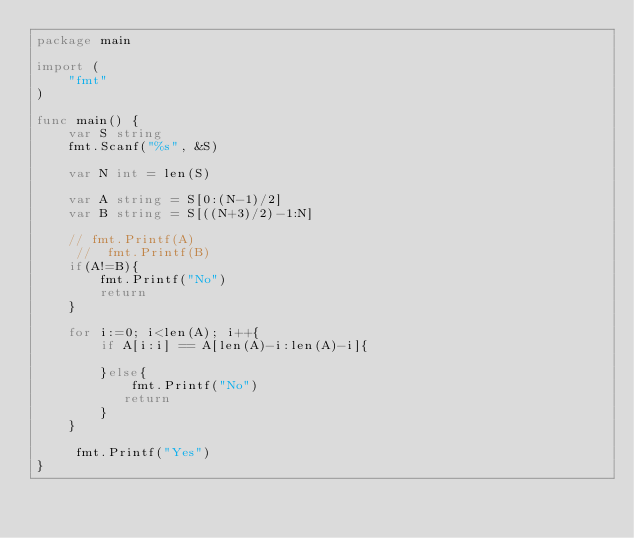Convert code to text. <code><loc_0><loc_0><loc_500><loc_500><_Go_>package main
 
import (
	"fmt"
)
 
func main() {
	var S string
	fmt.Scanf("%s", &S)
	
	var N int = len(S)
	
	var A string = S[0:(N-1)/2]
	var B string = S[((N+3)/2)-1:N]
	
	// fmt.Printf(A)
	 //	 fmt.Printf(B)
	if(A!=B){
	    fmt.Printf("No")
	    return
	}
	
	for i:=0; i<len(A); i++{
	    if A[i:i] == A[len(A)-i:len(A)-i]{
	       
	    }else{
	        fmt.Printf("No")
	       return  
	    }
	}

     fmt.Printf("Yes")
}</code> 